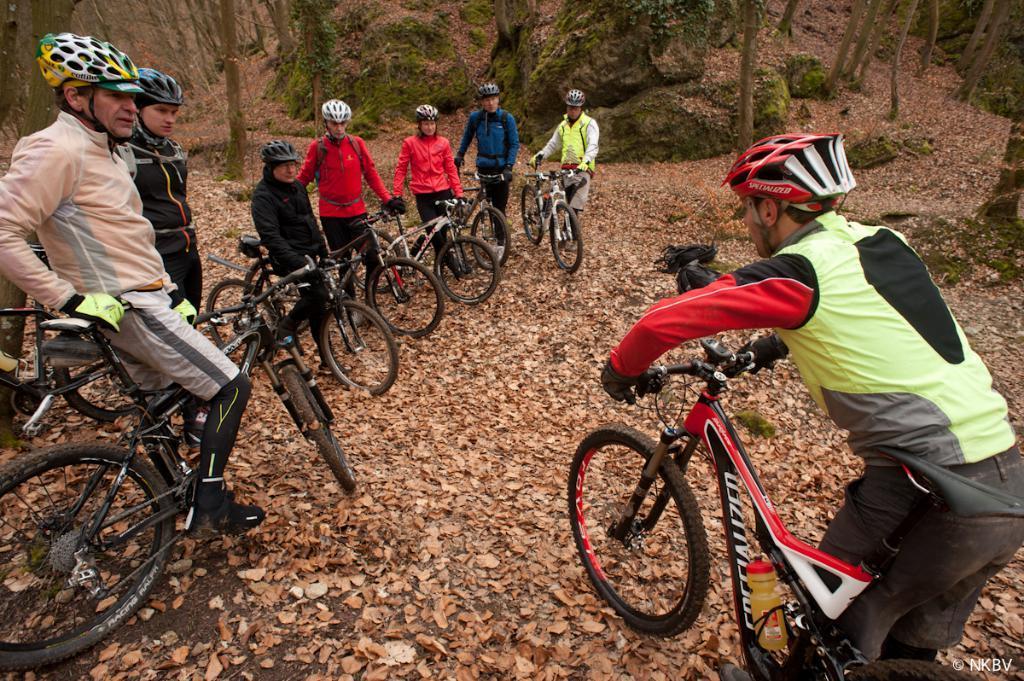Please provide a concise description of this image. In this image we can see few people wearing helmets holding cycles, there are some trees and we can see leafs on the ground. 